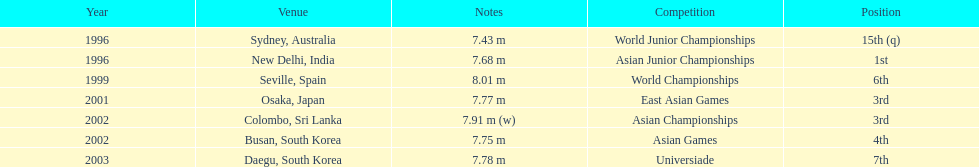How many times did his jump surpass 7.70 m? 5. Give me the full table as a dictionary. {'header': ['Year', 'Venue', 'Notes', 'Competition', 'Position'], 'rows': [['1996', 'Sydney, Australia', '7.43 m', 'World Junior Championships', '15th (q)'], ['1996', 'New Delhi, India', '7.68 m', 'Asian Junior Championships', '1st'], ['1999', 'Seville, Spain', '8.01 m', 'World Championships', '6th'], ['2001', 'Osaka, Japan', '7.77 m', 'East Asian Games', '3rd'], ['2002', 'Colombo, Sri Lanka', '7.91 m (w)', 'Asian Championships', '3rd'], ['2002', 'Busan, South Korea', '7.75 m', 'Asian Games', '4th'], ['2003', 'Daegu, South Korea', '7.78 m', 'Universiade', '7th']]} 